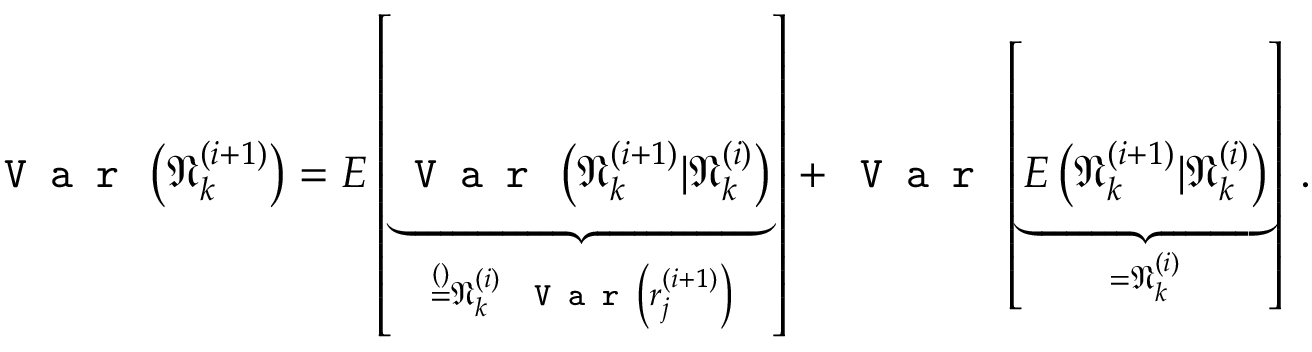<formula> <loc_0><loc_0><loc_500><loc_500>V a r \left ( \mathfrak { N } _ { k } ^ { ( i + 1 ) } \right ) = E \left [ \underbrace { V a r \left ( \mathfrak { N } _ { k } ^ { ( i + 1 ) } | \mathfrak { N } _ { k } ^ { ( i ) } \right ) } _ { \stackrel { ( ) } { = } \mathfrak { N } _ { k } ^ { ( i ) } V a r \left ( r _ { j } ^ { ( i + 1 ) } \right ) } \right ] + V a r \left [ \underbrace { E \left ( \mathfrak { N } _ { k } ^ { ( i + 1 ) } | \mathfrak { N } _ { k } ^ { ( i ) } \right ) } _ { = \mathfrak { N } _ { k } ^ { ( i ) } } \right ] \, .</formula> 